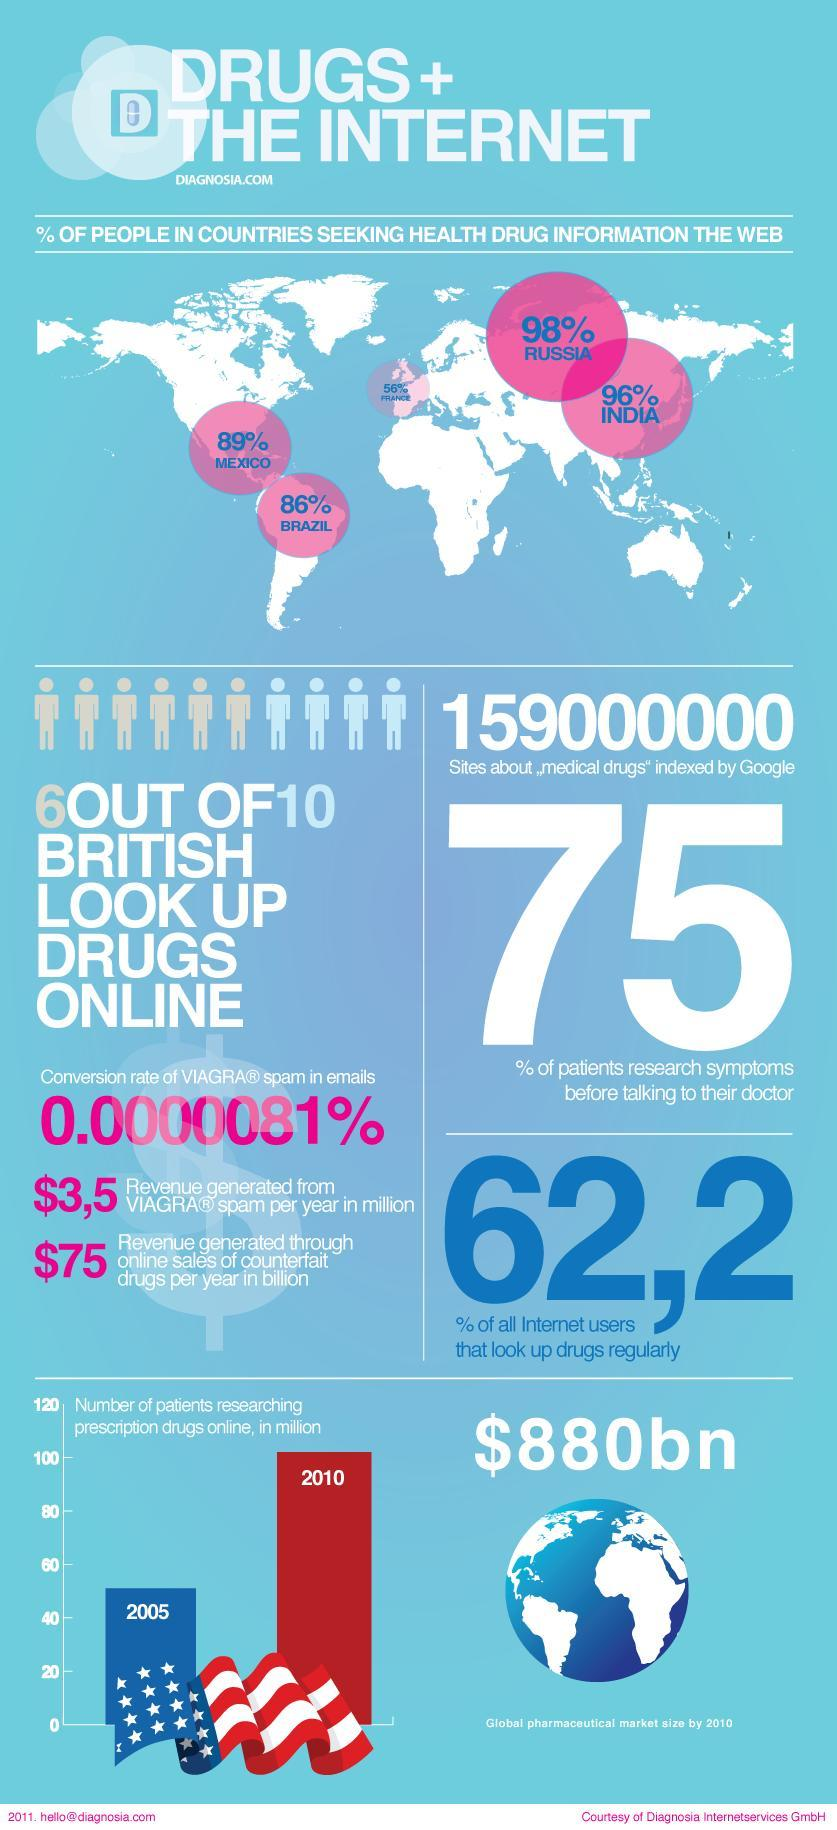What percentage of people do not research symptoms before talking to their doctor?
Answer the question with a short phrase. 25% What percentage of people in Mexico are seeking health drug information on the web ? 89% What percentage of people in India are seeking health drug information on the web ? 96% 